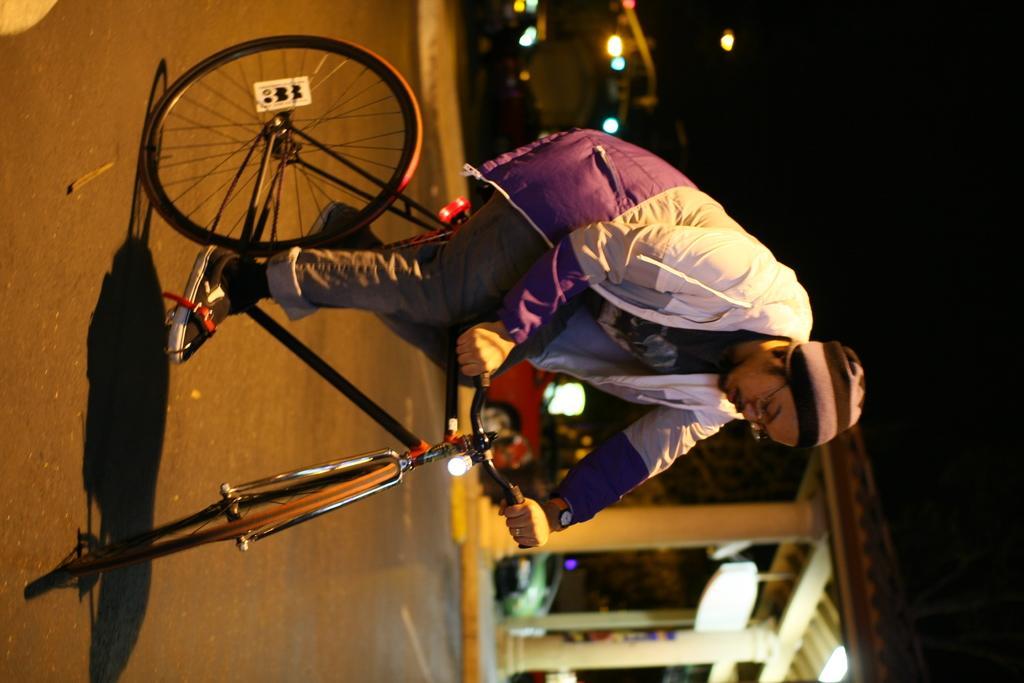In one or two sentences, can you explain what this image depicts? There is a man wearing a cap and spectacles riding a bicycle on the road. In the background there is shed and a light here. 